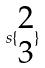Convert formula to latex. <formula><loc_0><loc_0><loc_500><loc_500>s \{ \begin{matrix} 2 \\ 3 \end{matrix} \}</formula> 